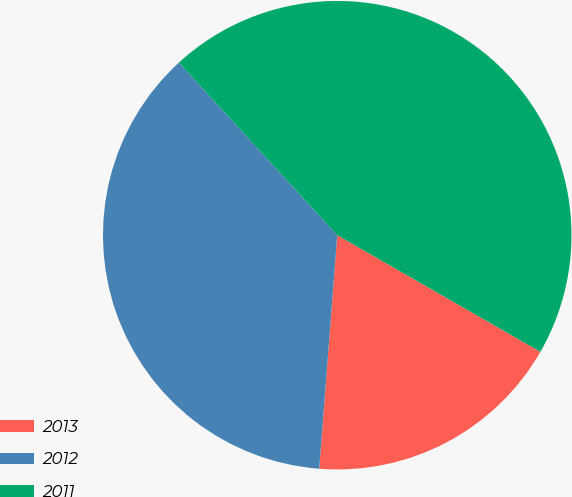Convert chart. <chart><loc_0><loc_0><loc_500><loc_500><pie_chart><fcel>2013<fcel>2012<fcel>2011<nl><fcel>17.93%<fcel>36.96%<fcel>45.11%<nl></chart> 